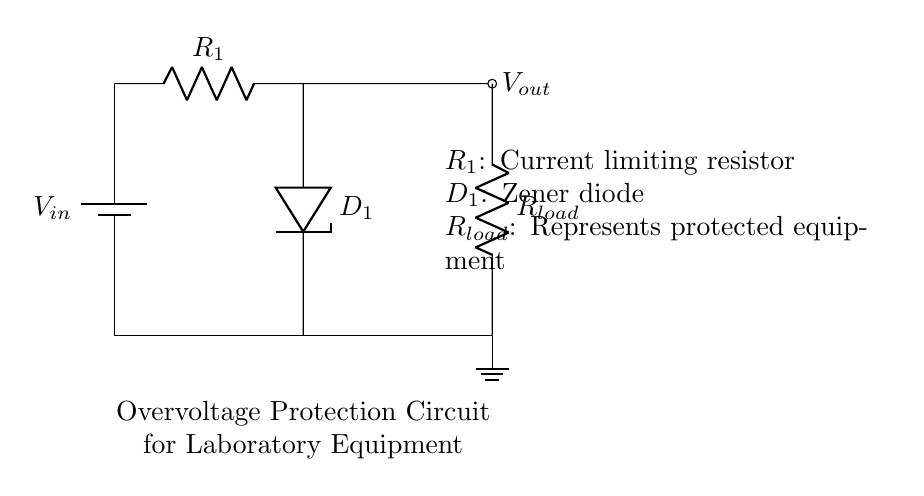What is the input voltage of this circuit? The input voltage is labeled as V-in in the circuit diagram, indicating the voltage supplied to the circuit.
Answer: V-in What type of component is D1? D1 is labeled as a Zener diode in the circuit diagram, which specifically allows current to flow in the reverse direction when the voltage exceeds a certain level.
Answer: Zener diode What is the purpose of R1? R1 is labeled as a current limiting resistor, which is used to restrict the amount of current flowing through the circuit to protect sensitive components.
Answer: Current limiting resistor What happens if the input voltage exceeds the Zener breakdown voltage? If the input voltage exceeds the Zener breakdown voltage, the Zener diode D1 conducts, shunting excess voltage and protecting the load R-load from an overvoltage condition.
Answer: It conducts What is represented by R-load? R-load represents the delicate laboratory equipment being protected by the overvoltage protection circuit from excessive voltage levels that could damage it.
Answer: Protected equipment How does this circuit protect equipment from overvoltage? This circuit protects equipment from overvoltage by utilizing the Zener diode, which clamps the voltage to a predetermined level, preventing higher voltage from reaching the load.
Answer: By clamping voltage 